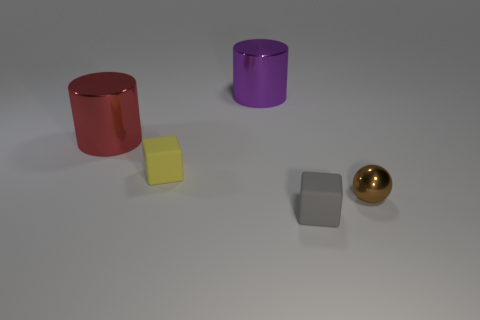Subtract all red cylinders. How many cylinders are left? 1 Subtract all cylinders. How many objects are left? 3 Add 3 gray rubber objects. How many gray rubber objects exist? 4 Add 2 tiny blocks. How many objects exist? 7 Subtract 0 blue blocks. How many objects are left? 5 Subtract 2 cylinders. How many cylinders are left? 0 Subtract all cyan cylinders. Subtract all cyan balls. How many cylinders are left? 2 Subtract all gray cylinders. How many gray blocks are left? 1 Subtract all yellow objects. Subtract all brown metallic objects. How many objects are left? 3 Add 2 gray blocks. How many gray blocks are left? 3 